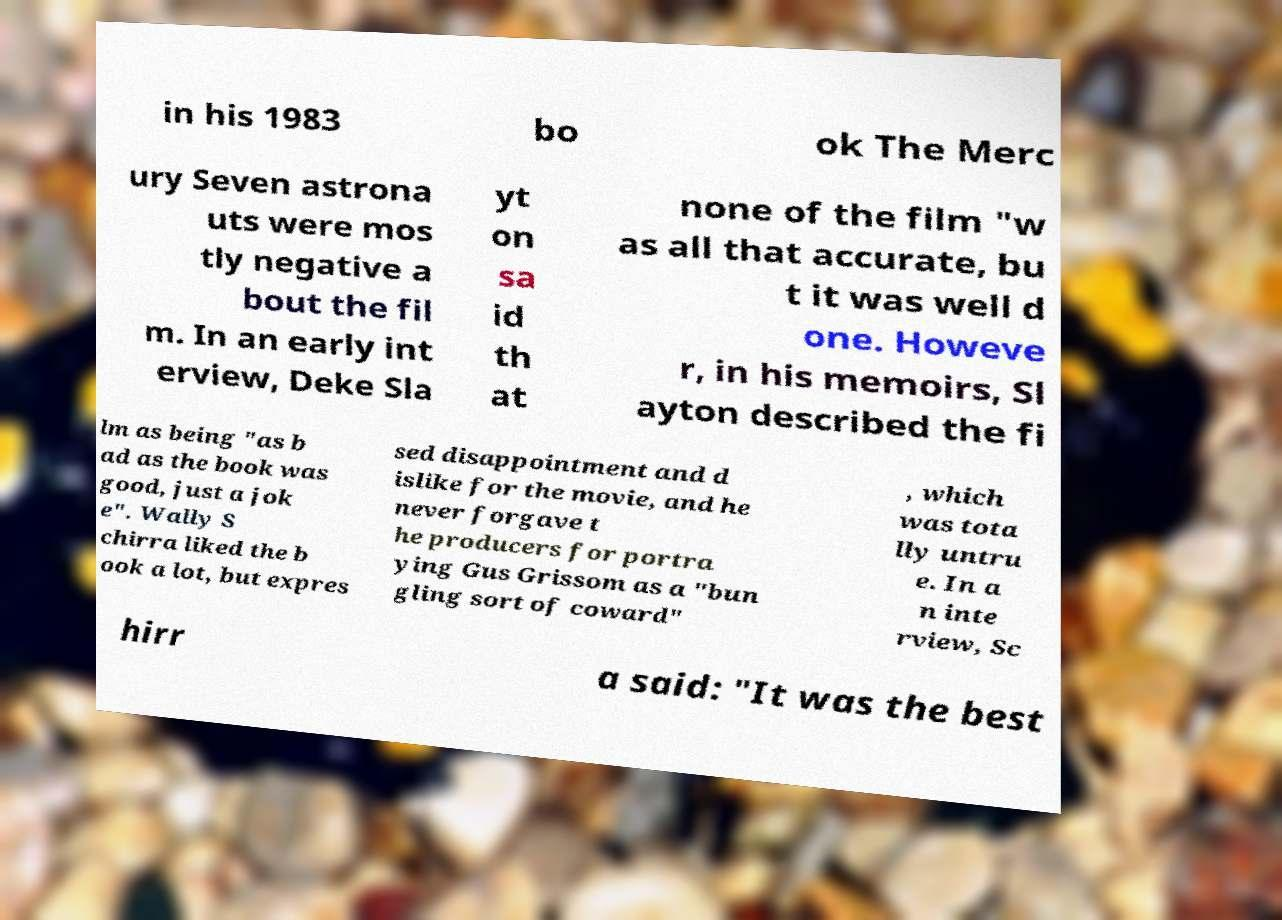Can you accurately transcribe the text from the provided image for me? in his 1983 bo ok The Merc ury Seven astrona uts were mos tly negative a bout the fil m. In an early int erview, Deke Sla yt on sa id th at none of the film "w as all that accurate, bu t it was well d one. Howeve r, in his memoirs, Sl ayton described the fi lm as being "as b ad as the book was good, just a jok e". Wally S chirra liked the b ook a lot, but expres sed disappointment and d islike for the movie, and he never forgave t he producers for portra ying Gus Grissom as a "bun gling sort of coward" , which was tota lly untru e. In a n inte rview, Sc hirr a said: "It was the best 